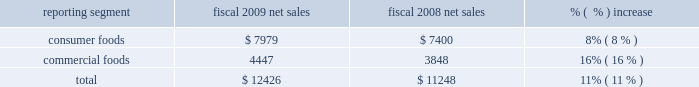Credits and deductions identified in fiscal 2010 that related to prior periods .
These benefits were offset , in part , by unfavorable tax consequences of the patient protection and affordable care act and the health care and education reconciliation act of 2010 .
The company expects its effective tax rate in fiscal 2011 , exclusive of any unusual transactions or tax events , to be approximately 34% ( 34 % ) .
Equity method investment earnings we include our share of the earnings of certain affiliates based on our economic ownership interest in the affiliates .
Significant affiliates produce and market potato products for retail and foodservice customers .
Our share of earnings from our equity method investments was $ 22 million ( $ 2 million in the consumer foods segment and $ 20 million in the commercial foods segment ) and $ 24 million ( $ 3 million in the consumer foods segment and $ 21 million in the commercial foods segment ) in fiscal 2010 and 2009 , respectively .
Equity method investment earnings in the commercial foods segment reflects continued difficult market conditions for our foreign and domestic potato ventures .
Results of discontinued operations our discontinued operations generated an after-tax loss of $ 22 million in fiscal 2010 and earnings of $ 361 million in fiscal 2009 .
In fiscal 2010 , we decided to divest our dehydrated vegetable operations .
As a result of this decision , we recognized an after-tax impairment charge of $ 40 million in fiscal 2010 , representing a write- down of the carrying value of the related long-lived assets to fair value , based on the anticipated sales proceeds .
In fiscal 2009 , we completed the sale of the trading and merchandising operations and recognized an after-tax gain on the disposition of approximately $ 301 million .
In the fourth quarter of fiscal 2009 , we decided to sell certain small foodservice brands .
The sale of these brands was completed in june 2009 .
We recognized after-tax impairment charges of $ 6 million in fiscal 2009 , in anticipation of this divestiture .
Earnings per share our diluted earnings per share in fiscal 2010 were $ 1.62 ( including earnings of $ 1.67 per diluted share from continuing operations and a loss of $ 0.05 per diluted share from discontinued operations ) .
Our diluted earnings per share in fiscal 2009 were $ 2.15 ( including earnings of $ 1.36 per diluted share from continuing operations and $ 0.79 per diluted share from discontinued operations ) see 201citems impacting comparability 201d above as several other significant items affected the comparability of year-over-year results of operations .
2009 vs .
2008 net sales ( $ in millions ) reporting segment fiscal 2009 net sales fiscal 2008 net sales % (  % ) increase .
Overall , our net sales increased $ 1.18 billion to $ 12.43 billion in fiscal 2009 , reflecting improved pricing and mix in the consumer foods segment and increased pricing in the milling and specialty potato operations of the commercial foods segment , as well as an additional week in fiscal 2009 .
Consumer foods net sales for fiscal 2009 were $ 7.98 billion , an increase of 8% ( 8 % ) compared to fiscal 2008 .
Results reflected an increase of 7% ( 7 % ) from improved net pricing and product mix and flat volume .
Volume reflected a benefit of approximately 2% ( 2 % ) in fiscal 2009 due to the inclusion of an additional week of results .
The strengthening of the u.s .
Dollar relative to foreign currencies resulted in a reduction of net sales of approximately 1% ( 1 % ) as compared to fiscal 2008. .
What percentage of fiscal 2009 total net sales was due to commercial foods? 
Computations: (4447 / 12426)
Answer: 0.35788. 